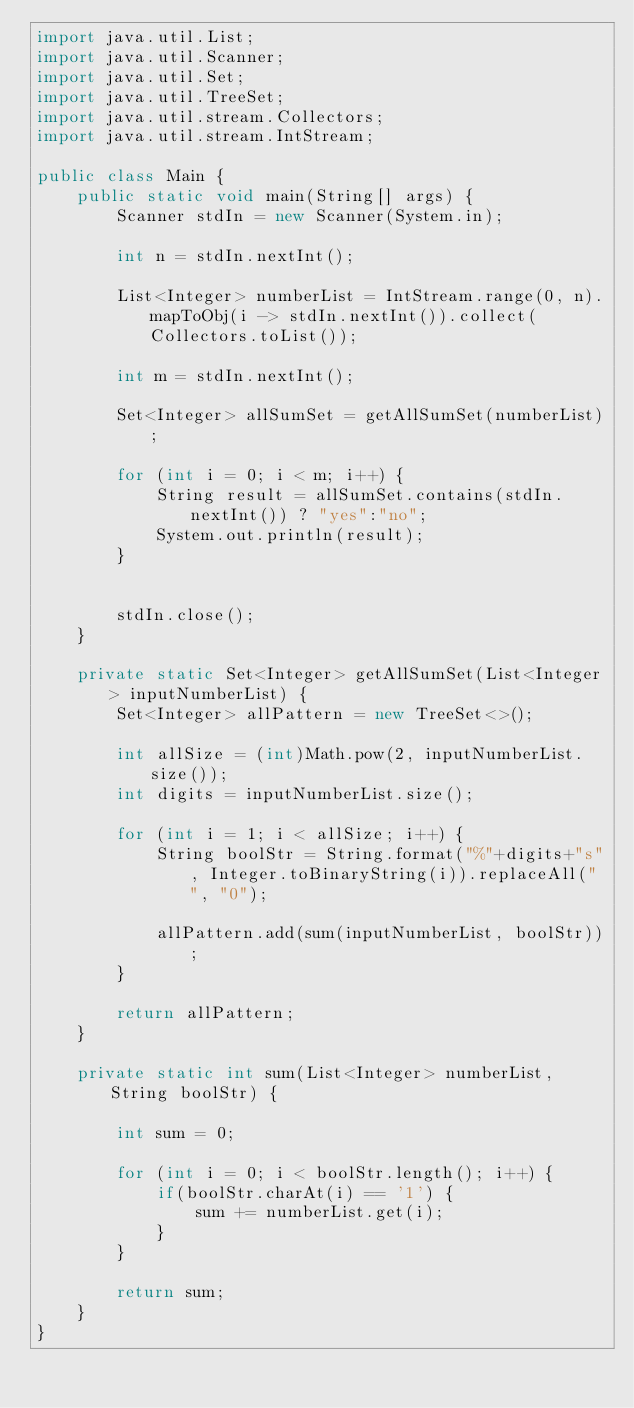Convert code to text. <code><loc_0><loc_0><loc_500><loc_500><_Java_>import java.util.List;
import java.util.Scanner;
import java.util.Set;
import java.util.TreeSet;
import java.util.stream.Collectors;
import java.util.stream.IntStream;

public class Main {
	public static void main(String[] args) {
		Scanner stdIn = new Scanner(System.in);

		int n = stdIn.nextInt();

		List<Integer> numberList = IntStream.range(0, n).mapToObj(i -> stdIn.nextInt()).collect(Collectors.toList());

		int m = stdIn.nextInt();

		Set<Integer> allSumSet = getAllSumSet(numberList);

		for (int i = 0; i < m; i++) {
			String result = allSumSet.contains(stdIn.nextInt()) ? "yes":"no";
			System.out.println(result);
		}


		stdIn.close();
	}

	private static Set<Integer> getAllSumSet(List<Integer> inputNumberList) {
		Set<Integer> allPattern = new TreeSet<>();

		int allSize = (int)Math.pow(2, inputNumberList.size());
		int digits = inputNumberList.size();

		for (int i = 1; i < allSize; i++) {
			String boolStr = String.format("%"+digits+"s", Integer.toBinaryString(i)).replaceAll(" ", "0");

			allPattern.add(sum(inputNumberList, boolStr));
		}

		return allPattern;
	}

	private static int sum(List<Integer> numberList, String boolStr) {

		int sum = 0;

		for (int i = 0; i < boolStr.length(); i++) {
			if(boolStr.charAt(i) == '1') {
				sum += numberList.get(i);
			}
		}

		return sum;
	}
}

</code> 